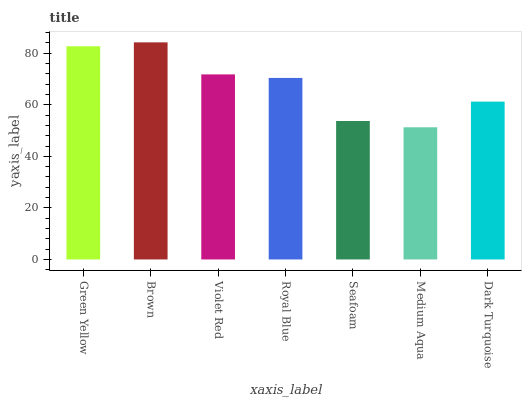Is Violet Red the minimum?
Answer yes or no. No. Is Violet Red the maximum?
Answer yes or no. No. Is Brown greater than Violet Red?
Answer yes or no. Yes. Is Violet Red less than Brown?
Answer yes or no. Yes. Is Violet Red greater than Brown?
Answer yes or no. No. Is Brown less than Violet Red?
Answer yes or no. No. Is Royal Blue the high median?
Answer yes or no. Yes. Is Royal Blue the low median?
Answer yes or no. Yes. Is Seafoam the high median?
Answer yes or no. No. Is Medium Aqua the low median?
Answer yes or no. No. 